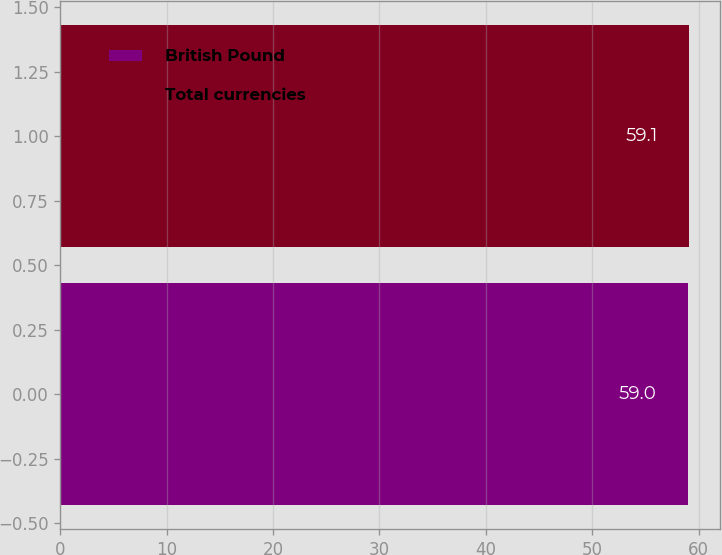Convert chart. <chart><loc_0><loc_0><loc_500><loc_500><bar_chart><fcel>British Pound<fcel>Total currencies<nl><fcel>59<fcel>59.1<nl></chart> 